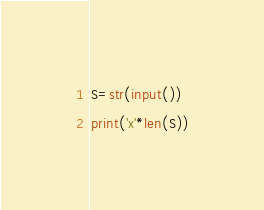<code> <loc_0><loc_0><loc_500><loc_500><_Python_>S=str(input())
print('x'*len(S))
</code> 